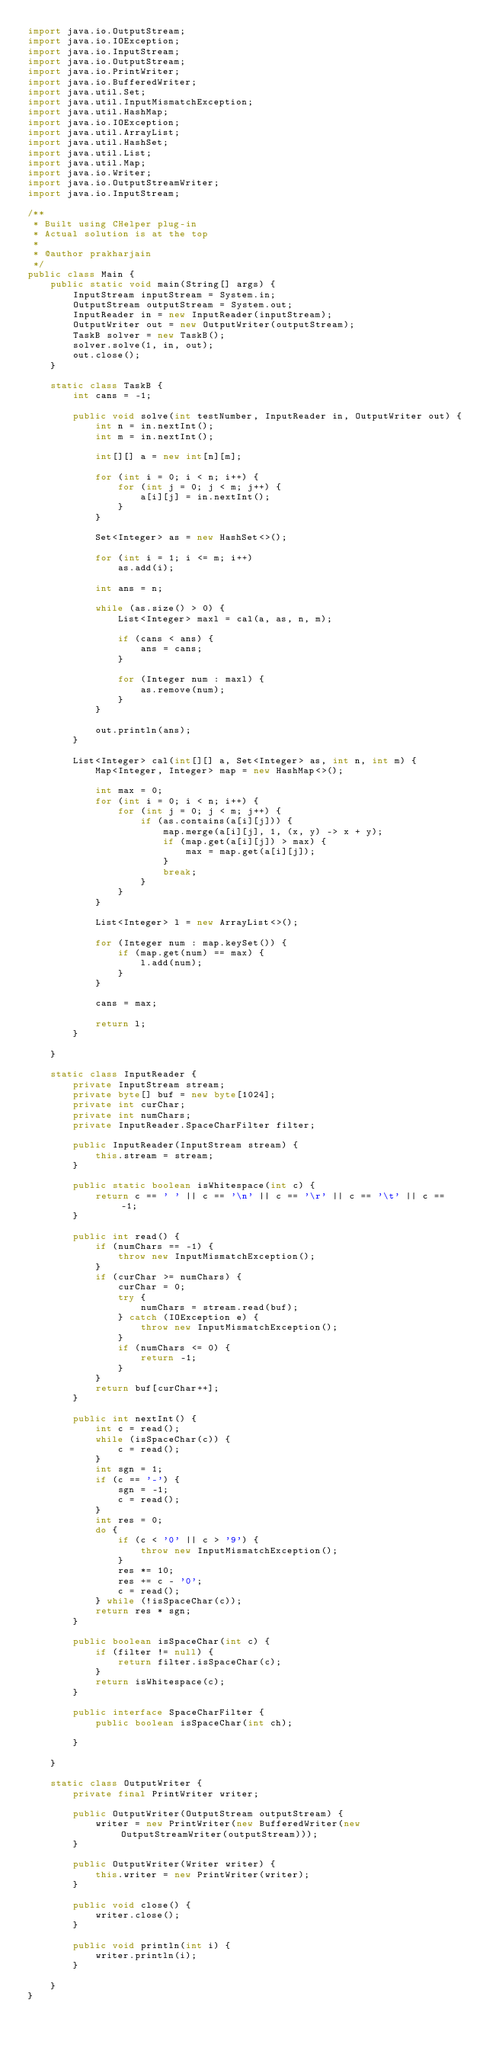<code> <loc_0><loc_0><loc_500><loc_500><_Java_>import java.io.OutputStream;
import java.io.IOException;
import java.io.InputStream;
import java.io.OutputStream;
import java.io.PrintWriter;
import java.io.BufferedWriter;
import java.util.Set;
import java.util.InputMismatchException;
import java.util.HashMap;
import java.io.IOException;
import java.util.ArrayList;
import java.util.HashSet;
import java.util.List;
import java.util.Map;
import java.io.Writer;
import java.io.OutputStreamWriter;
import java.io.InputStream;

/**
 * Built using CHelper plug-in
 * Actual solution is at the top
 *
 * @author prakharjain
 */
public class Main {
    public static void main(String[] args) {
        InputStream inputStream = System.in;
        OutputStream outputStream = System.out;
        InputReader in = new InputReader(inputStream);
        OutputWriter out = new OutputWriter(outputStream);
        TaskB solver = new TaskB();
        solver.solve(1, in, out);
        out.close();
    }

    static class TaskB {
        int cans = -1;

        public void solve(int testNumber, InputReader in, OutputWriter out) {
            int n = in.nextInt();
            int m = in.nextInt();

            int[][] a = new int[n][m];

            for (int i = 0; i < n; i++) {
                for (int j = 0; j < m; j++) {
                    a[i][j] = in.nextInt();
                }
            }

            Set<Integer> as = new HashSet<>();

            for (int i = 1; i <= m; i++)
                as.add(i);

            int ans = n;

            while (as.size() > 0) {
                List<Integer> maxl = cal(a, as, n, m);

                if (cans < ans) {
                    ans = cans;
                }

                for (Integer num : maxl) {
                    as.remove(num);
                }
            }

            out.println(ans);
        }

        List<Integer> cal(int[][] a, Set<Integer> as, int n, int m) {
            Map<Integer, Integer> map = new HashMap<>();

            int max = 0;
            for (int i = 0; i < n; i++) {
                for (int j = 0; j < m; j++) {
                    if (as.contains(a[i][j])) {
                        map.merge(a[i][j], 1, (x, y) -> x + y);
                        if (map.get(a[i][j]) > max) {
                            max = map.get(a[i][j]);
                        }
                        break;
                    }
                }
            }

            List<Integer> l = new ArrayList<>();

            for (Integer num : map.keySet()) {
                if (map.get(num) == max) {
                    l.add(num);
                }
            }

            cans = max;

            return l;
        }

    }

    static class InputReader {
        private InputStream stream;
        private byte[] buf = new byte[1024];
        private int curChar;
        private int numChars;
        private InputReader.SpaceCharFilter filter;

        public InputReader(InputStream stream) {
            this.stream = stream;
        }

        public static boolean isWhitespace(int c) {
            return c == ' ' || c == '\n' || c == '\r' || c == '\t' || c == -1;
        }

        public int read() {
            if (numChars == -1) {
                throw new InputMismatchException();
            }
            if (curChar >= numChars) {
                curChar = 0;
                try {
                    numChars = stream.read(buf);
                } catch (IOException e) {
                    throw new InputMismatchException();
                }
                if (numChars <= 0) {
                    return -1;
                }
            }
            return buf[curChar++];
        }

        public int nextInt() {
            int c = read();
            while (isSpaceChar(c)) {
                c = read();
            }
            int sgn = 1;
            if (c == '-') {
                sgn = -1;
                c = read();
            }
            int res = 0;
            do {
                if (c < '0' || c > '9') {
                    throw new InputMismatchException();
                }
                res *= 10;
                res += c - '0';
                c = read();
            } while (!isSpaceChar(c));
            return res * sgn;
        }

        public boolean isSpaceChar(int c) {
            if (filter != null) {
                return filter.isSpaceChar(c);
            }
            return isWhitespace(c);
        }

        public interface SpaceCharFilter {
            public boolean isSpaceChar(int ch);

        }

    }

    static class OutputWriter {
        private final PrintWriter writer;

        public OutputWriter(OutputStream outputStream) {
            writer = new PrintWriter(new BufferedWriter(new OutputStreamWriter(outputStream)));
        }

        public OutputWriter(Writer writer) {
            this.writer = new PrintWriter(writer);
        }

        public void close() {
            writer.close();
        }

        public void println(int i) {
            writer.println(i);
        }

    }
}

</code> 